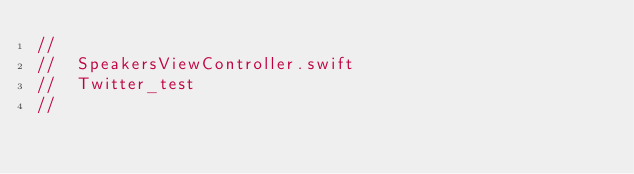<code> <loc_0><loc_0><loc_500><loc_500><_Swift_>//
//  SpeakersViewController.swift
//  Twitter_test
//</code> 